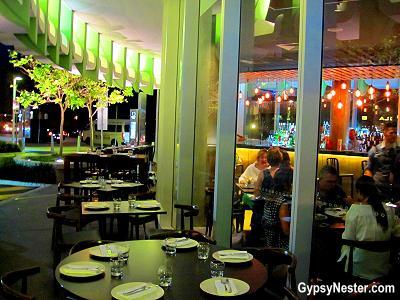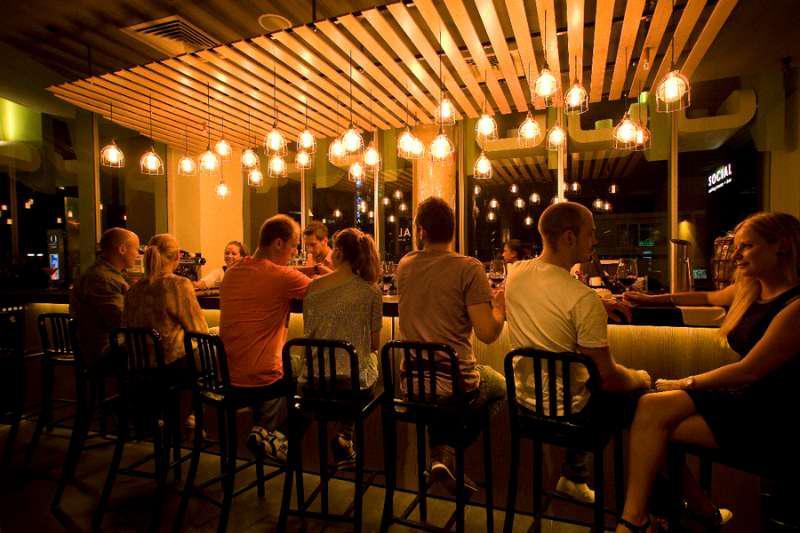The first image is the image on the left, the second image is the image on the right. Assess this claim about the two images: "There are people dining in a restaurant with exposed lit bulbs haning from the ceiling". Correct or not? Answer yes or no. Yes. The first image is the image on the left, the second image is the image on the right. Given the left and right images, does the statement "The left image shows patrons dining at an establishment that features a curve of greenish columns, with a tree visible on the exterior." hold true? Answer yes or no. Yes. 